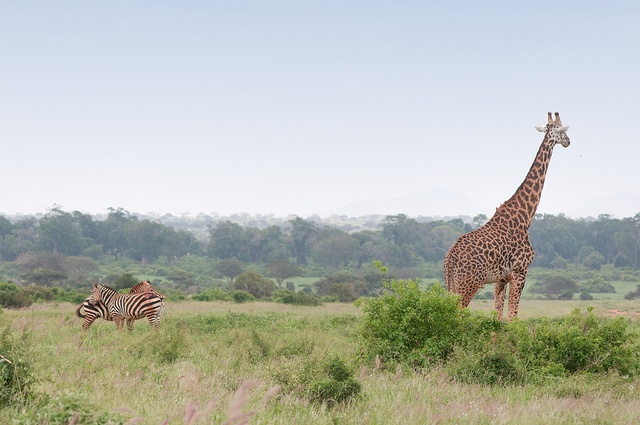Describe the objects in this image and their specific colors. I can see giraffe in lavender, gray, brown, and tan tones, zebra in lavender, gray, black, and tan tones, and zebra in lavender, gray, black, and maroon tones in this image. 